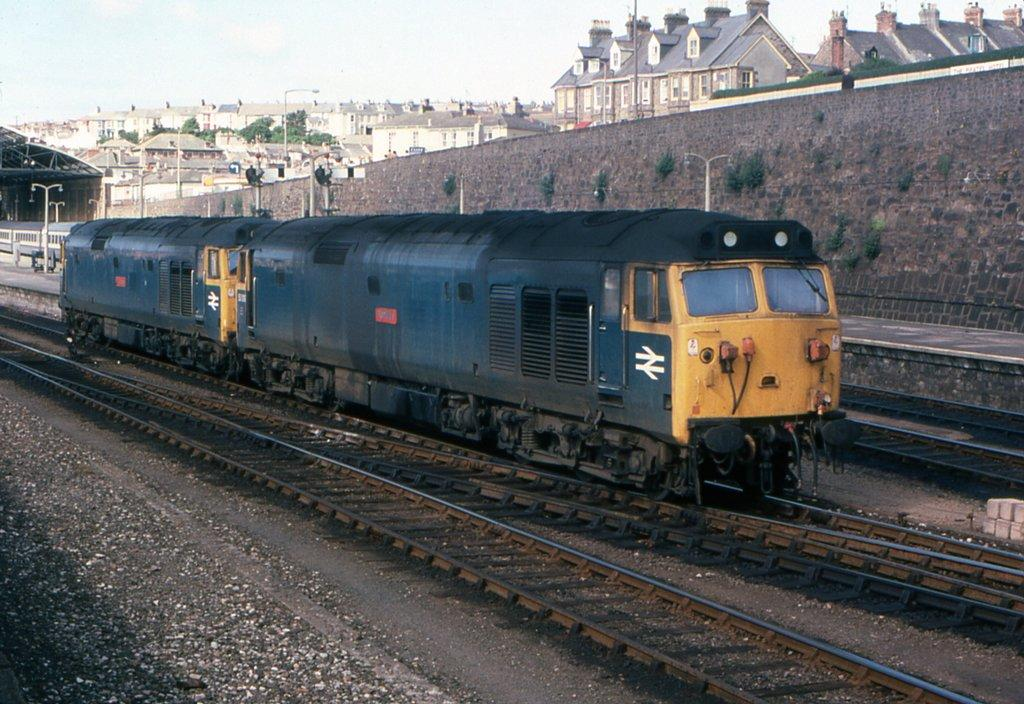What type of vehicles can be seen on the railway tracks in the image? There are trains on the railway tracks in the image. What structure is present near the railway tracks? There is a platform in the image. What can be seen illuminating the area in the image? There are lights in the image. What objects are supporting the lights or cables in the image? There are poles in the image. What type of structures are visible in the image? There are buildings in the image. What type of vegetation is present in the image? There are trees in the image. What is visible in the background of the image? The sky is visible in the background of the image. Where is the hammer being used in the image? There is no hammer present in the image. Can you tell me how many people are getting a haircut in the image? There is no haircut or person getting a haircut present in the image. 